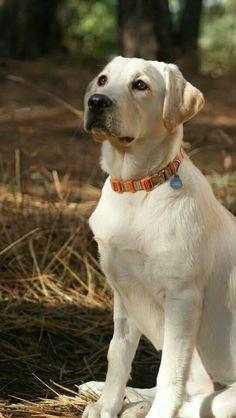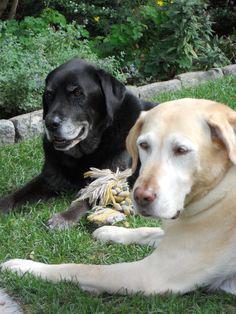The first image is the image on the left, the second image is the image on the right. For the images displayed, is the sentence "There are three dogs in total." factually correct? Answer yes or no. Yes. The first image is the image on the left, the second image is the image on the right. Examine the images to the left and right. Is the description "An image contains exactly two dogs." accurate? Answer yes or no. Yes. 